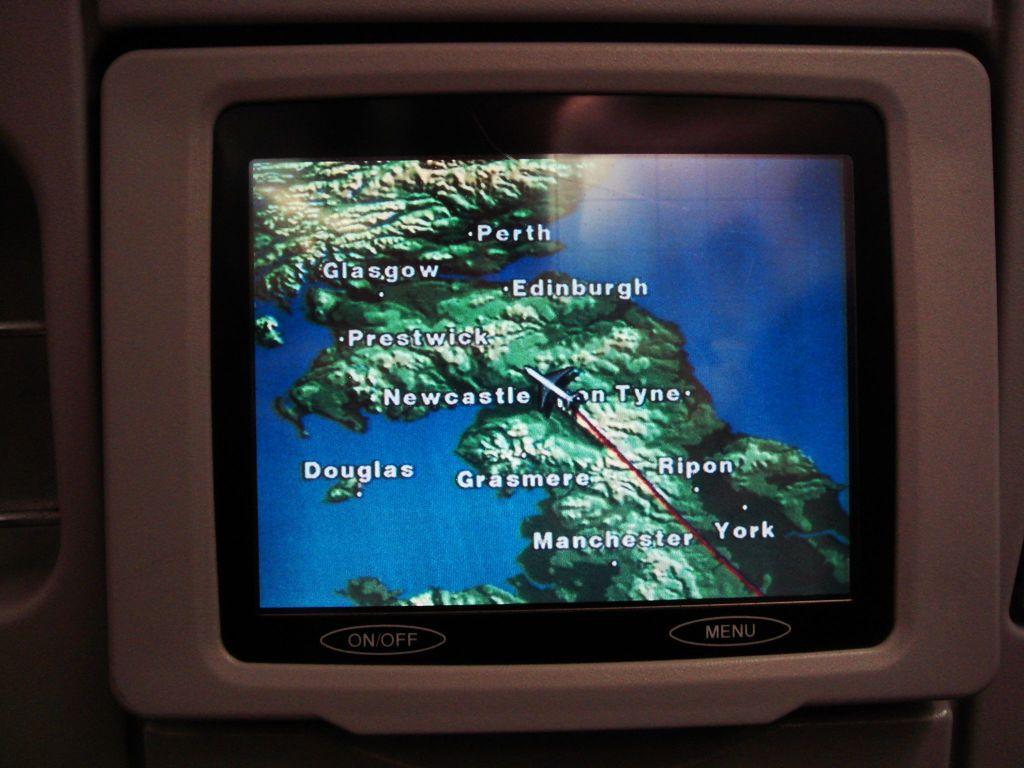<image>
Render a clear and concise summary of the photo. A screen showing various city names including Perth and Glasgow. 